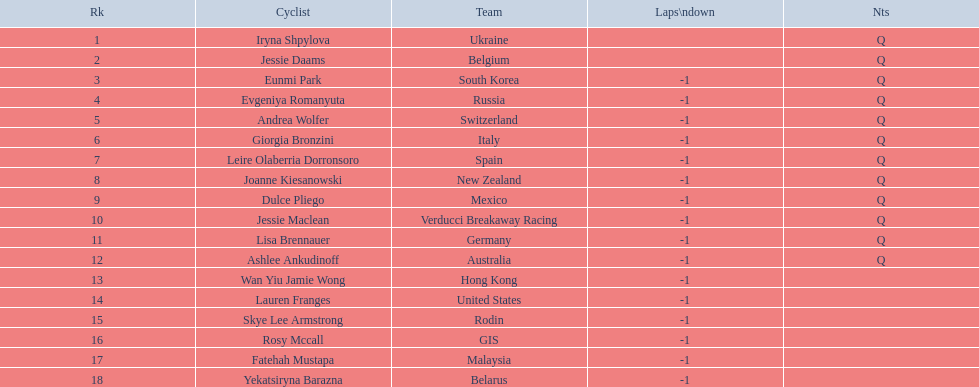Who is the last cyclist listed? Yekatsiryna Barazna. 